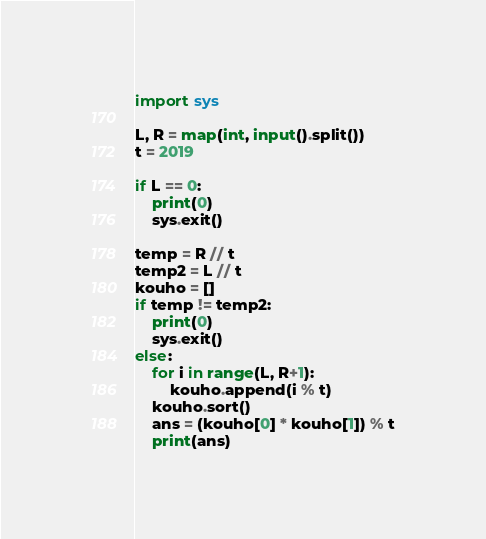<code> <loc_0><loc_0><loc_500><loc_500><_Python_>import sys

L, R = map(int, input().split())
t = 2019

if L == 0:
    print(0)
    sys.exit()

temp = R // t
temp2 = L // t
kouho = []
if temp != temp2:
    print(0)
    sys.exit()
else:
    for i in range(L, R+1):
        kouho.append(i % t)
    kouho.sort()
    ans = (kouho[0] * kouho[1]) % t
    print(ans)</code> 